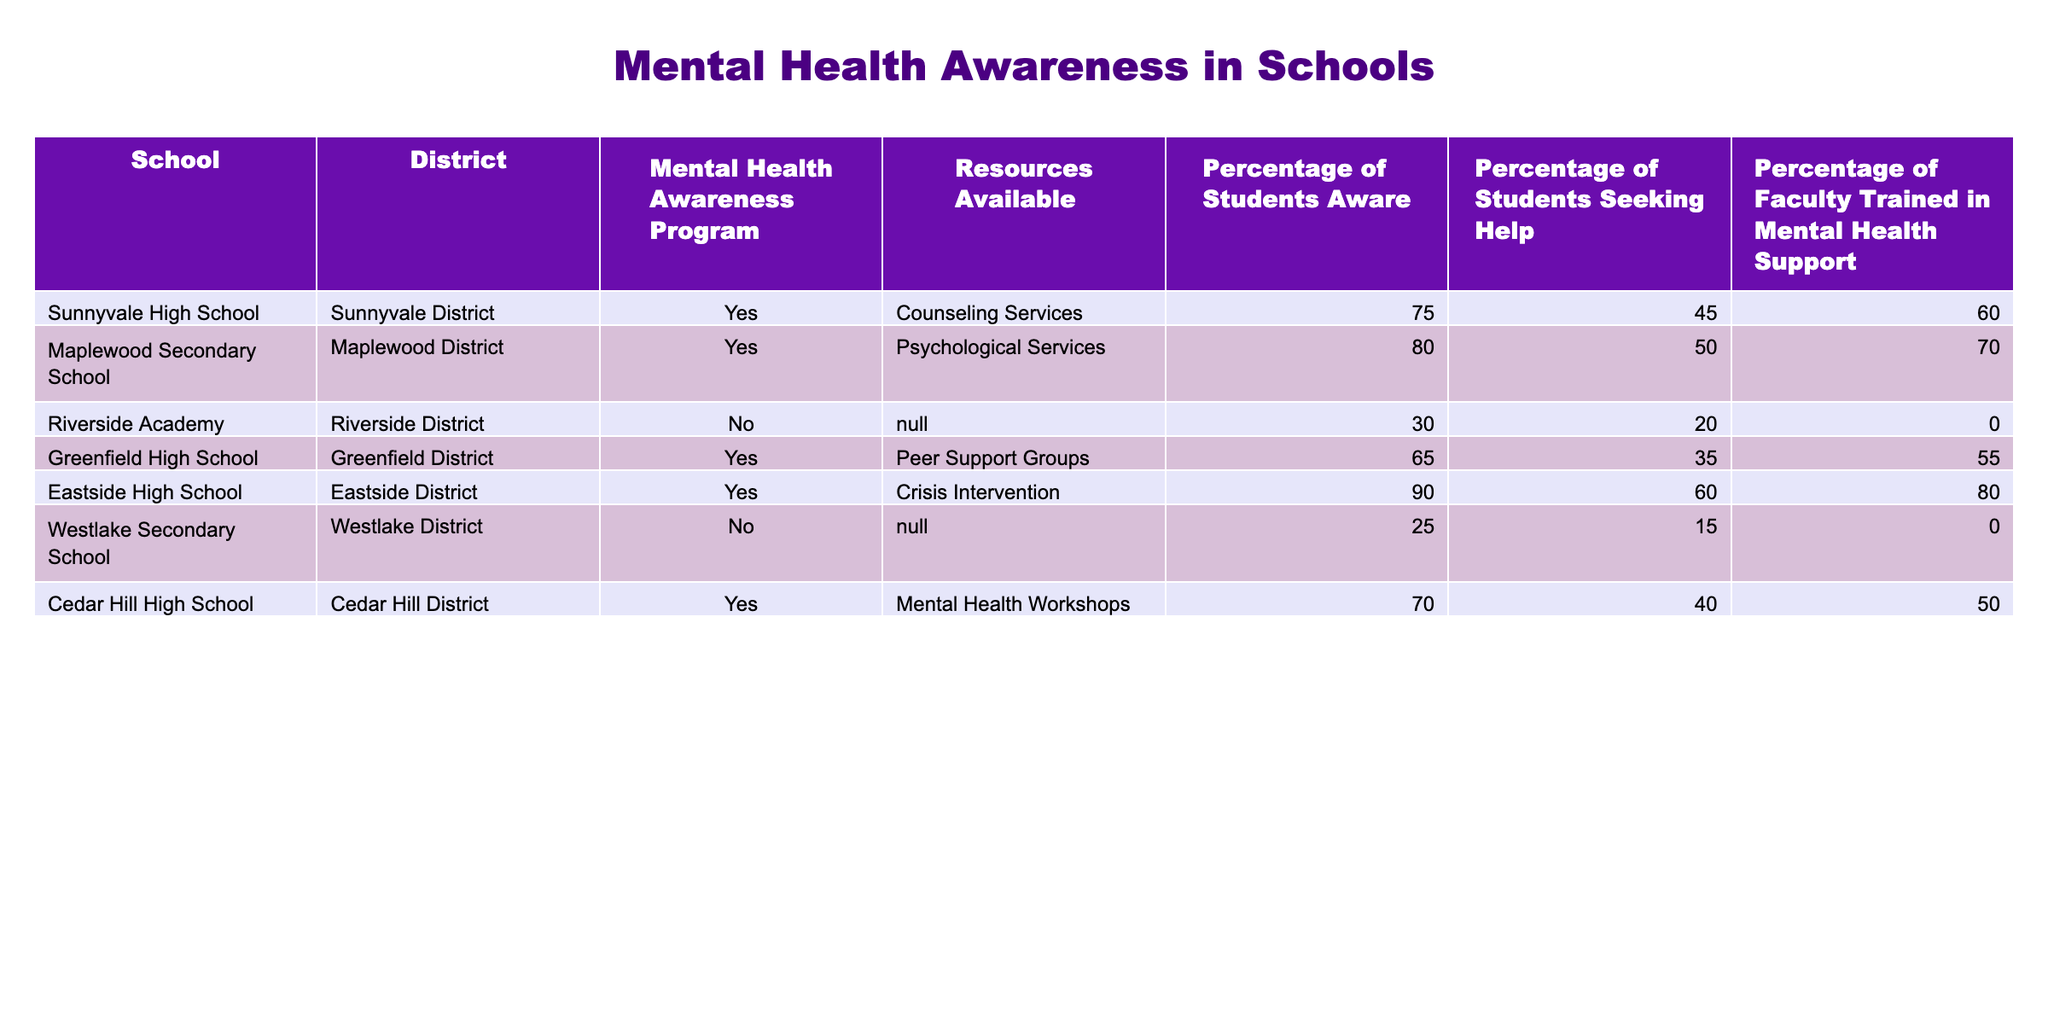What percentage of students at Eastside High School are aware of mental health resources? According to the table, the percentage of students aware at Eastside High School is listed directly in the "Percentage of Students Aware" column, which shows 90%.
Answer: 90% Which school has the lowest percentage of students seeking help? By comparing the "Percentage of Students Seeking Help" column values, Riverside Academy has the lowest percentage at 20%, as it is lower than Westlake Secondary School's 15%.
Answer: Riverside Academy Is there a mental health awareness program at Cedar Hill High School? Looking at the "Mental Health Awareness Program" column, Cedar Hill High School has "Yes" indicated, meaning there is a program in place.
Answer: Yes What is the average percentage of students aware of mental health resources across all schools? First, we identify the percentages from the "Percentage of Students Aware" column: 75, 80, 30, 65, 90, 25, 70. We sum these percentages to get 75 + 80 + 30 + 65 + 90 + 25 + 70 = 435. There are 7 schools, so the average is 435 / 7 = 62.14.
Answer: 62.14 True or False: All schools listed have mental health support resources available. Examining the "Resources Available" column, Riverside Academy and Westlake Secondary School are marked "N/A," indicating they lack resources. Thus, the statement is false.
Answer: False Which school has the highest percentage of faculty trained in mental health support? By checking the "Percentage of Faculty Trained in Mental Health Support" column, Eastside High School shows the highest percentage at 80%.
Answer: Eastside High School What is the difference in the percentage of students seeking help between Maplewood Secondary School and Greenfield High School? Maplewood Secondary School has 50% seeking help, while Greenfield High School has 35%. The difference is 50% - 35% = 15%.
Answer: 15% How many schools have mental health awareness programs? By counting the "Mental Health Awareness Program" column, we find 5 schools indicated "Yes" out of a total of 7 schools listed in the table.
Answer: 5 